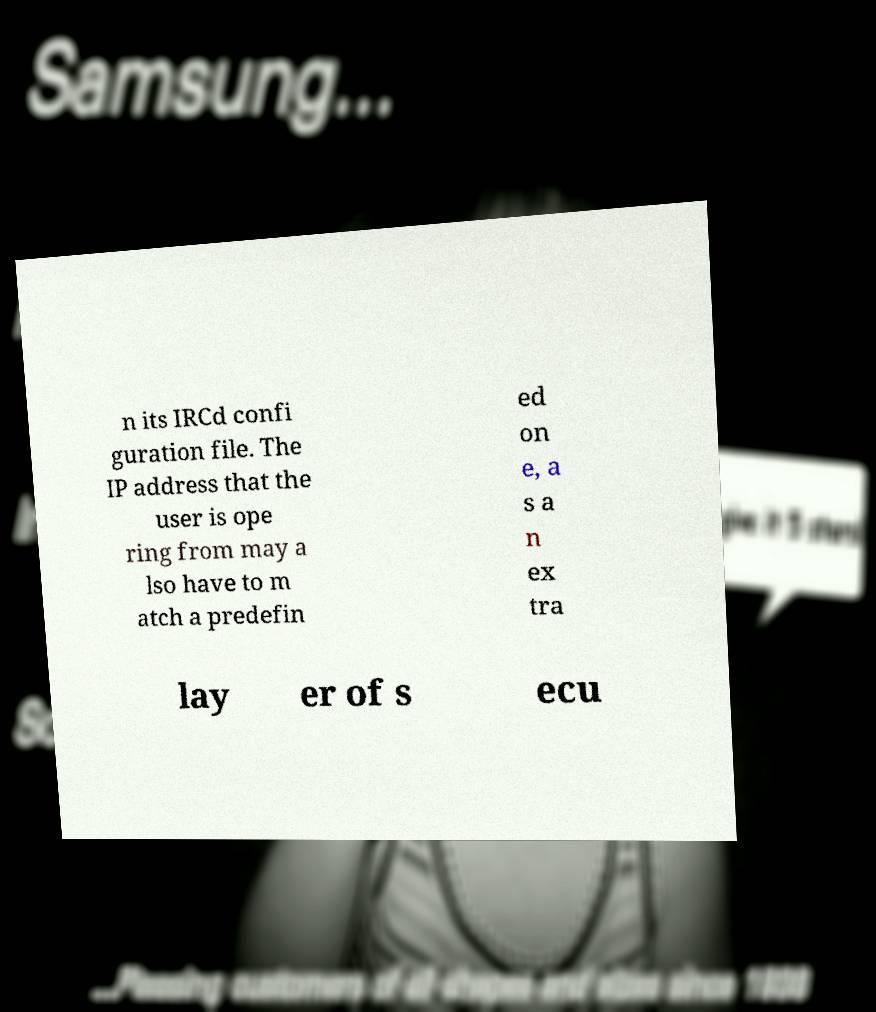I need the written content from this picture converted into text. Can you do that? n its IRCd confi guration file. The IP address that the user is ope ring from may a lso have to m atch a predefin ed on e, a s a n ex tra lay er of s ecu 